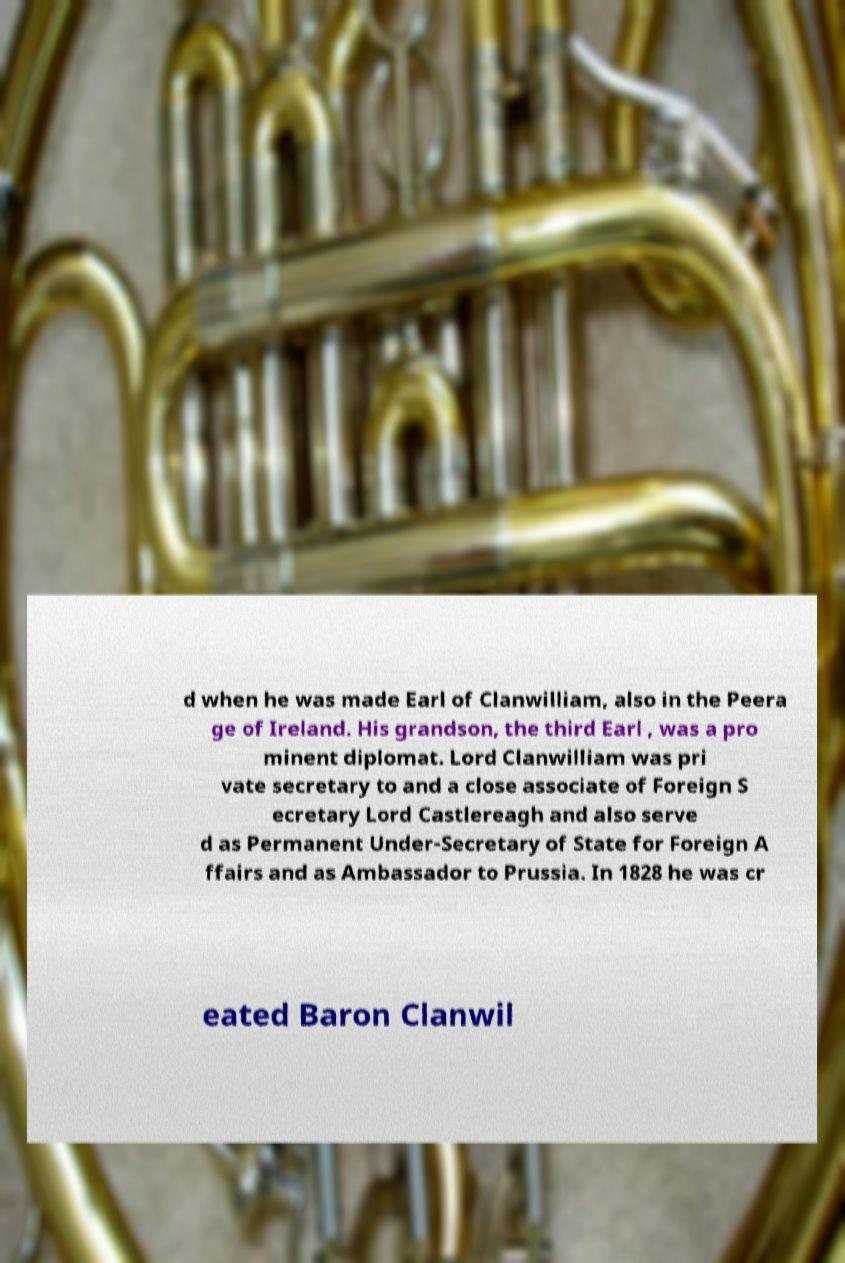There's text embedded in this image that I need extracted. Can you transcribe it verbatim? d when he was made Earl of Clanwilliam, also in the Peera ge of Ireland. His grandson, the third Earl , was a pro minent diplomat. Lord Clanwilliam was pri vate secretary to and a close associate of Foreign S ecretary Lord Castlereagh and also serve d as Permanent Under-Secretary of State for Foreign A ffairs and as Ambassador to Prussia. In 1828 he was cr eated Baron Clanwil 